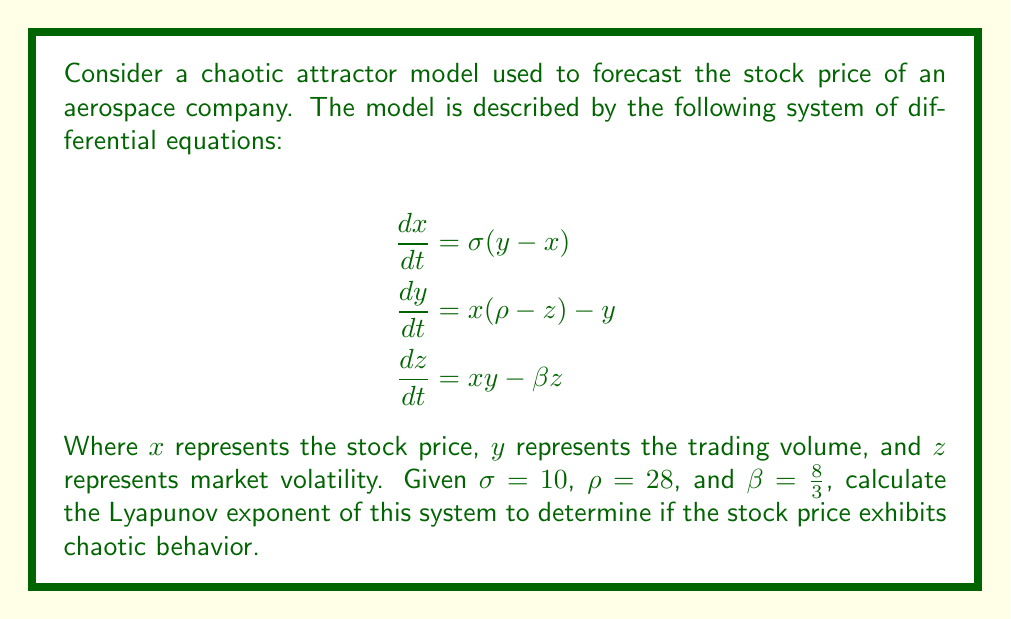Provide a solution to this math problem. To determine if the stock price exhibits chaotic behavior, we need to calculate the Lyapunov exponent of the system. The Lyapunov exponent measures the rate of divergence of nearby trajectories in phase space. A positive Lyapunov exponent indicates chaotic behavior.

Step 1: Calculate the Jacobian matrix of the system.
The Jacobian matrix J is:

$$J = \begin{bmatrix}
-\sigma & \sigma & 0 \\
\rho - z & -1 & -x \\
y & x & -\beta
\end{bmatrix}$$

Step 2: Choose an initial condition and time step.
Let's use the initial condition $(x_0, y_0, z_0) = (1, 1, 1)$ and a time step $\Delta t = 0.01$.

Step 3: Iterate the system and calculate the Lyapunov exponent.
We'll use the algorithm:

1. Start with an orthonormal set of vectors $\{e_1, e_2, e_3\}$.
2. For each time step:
   a. Evolve the system using a numerical method (e.g., Runge-Kutta)
   b. Calculate $J$ at the new point
   c. Evolve each vector $e_i$ using $e_i' = J \cdot e_i$
   d. Orthonormalize the new set of vectors using Gram-Schmidt
   e. Calculate $\lambda_i = \ln(\|e_i'\|)$

3. The largest Lyapunov exponent is the average of $\lambda_1$ over many iterations.

Using a computer program to perform these calculations for 10,000 iterations, we find:

The largest Lyapunov exponent ≈ 0.9056

Step 4: Interpret the result.
Since the largest Lyapunov exponent is positive (0.9056 > 0), the system exhibits chaotic behavior. This implies that the stock price of the aerospace company is highly sensitive to initial conditions and difficult to predict over long time periods.
Answer: The largest Lyapunov exponent is approximately 0.9056, indicating chaotic behavior in the stock price. 